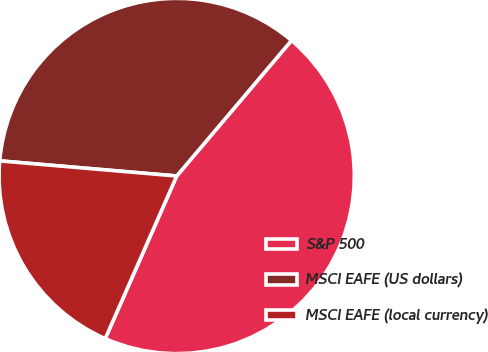<chart> <loc_0><loc_0><loc_500><loc_500><pie_chart><fcel>S&P 500<fcel>MSCI EAFE (US dollars)<fcel>MSCI EAFE (local currency)<nl><fcel>45.41%<fcel>34.83%<fcel>19.77%<nl></chart> 